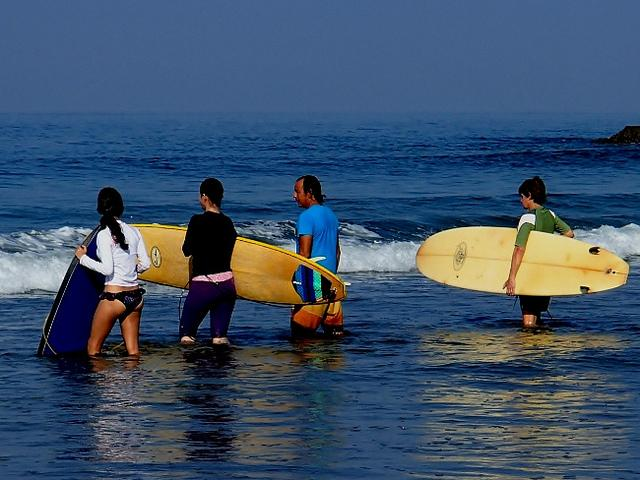What type of surfboard does the woman with the black pants have? Please explain your reasoning. gun. The woman's board is flatter, thicker, and straighter. 